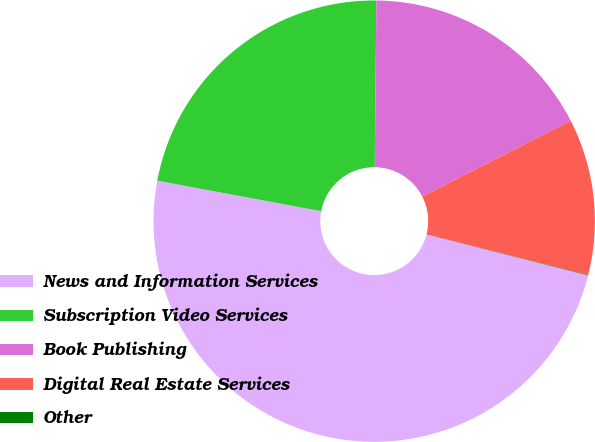Convert chart to OTSL. <chart><loc_0><loc_0><loc_500><loc_500><pie_chart><fcel>News and Information Services<fcel>Subscription Video Services<fcel>Book Publishing<fcel>Digital Real Estate Services<fcel>Other<nl><fcel>48.97%<fcel>22.22%<fcel>17.33%<fcel>11.45%<fcel>0.03%<nl></chart> 